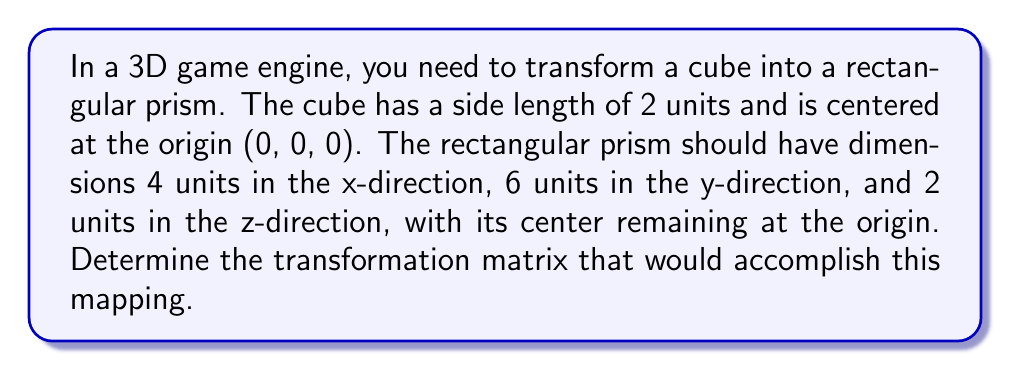Provide a solution to this math problem. To solve this problem, we need to follow these steps:

1) First, let's consider the transformation needed for each dimension:
   - x-axis: from 2 to 4 units (scale by 2)
   - y-axis: from 2 to 6 units (scale by 3)
   - z-axis: from 2 to 2 units (no change, scale by 1)

2) In 3D transformations, we use 4x4 matrices to represent scaling, rotation, and translation. The general form of a scaling matrix is:

   $$
   \begin{bmatrix}
   s_x & 0 & 0 & 0 \\
   0 & s_y & 0 & 0 \\
   0 & 0 & s_z & 0 \\
   0 & 0 & 0 & 1
   \end{bmatrix}
   $$

   where $s_x$, $s_y$, and $s_z$ are the scaling factors for x, y, and z axes respectively.

3) Substituting our scaling factors:

   $$
   \begin{bmatrix}
   2 & 0 & 0 & 0 \\
   0 & 3 & 0 & 0 \\
   0 & 0 & 1 & 0 \\
   0 & 0 & 0 & 1
   \end{bmatrix}
   $$

4) This matrix, when applied to any point $(x, y, z)$ of the cube, will transform it to the corresponding point on the rectangular prism:

   $$
   \begin{bmatrix}
   2 & 0 & 0 & 0 \\
   0 & 3 & 0 & 0 \\
   0 & 0 & 1 & 0 \\
   0 & 0 & 0 & 1
   \end{bmatrix}
   \begin{bmatrix}
   x \\
   y \\
   z \\
   1
   \end{bmatrix}
   =
   \begin{bmatrix}
   2x \\
   3y \\
   z \\
   1
   \end{bmatrix}
   $$

5) Note that we don't need any translation as both shapes are centered at the origin.
Answer: The transformation matrix to map the cube onto the rectangular prism is:

$$
\begin{bmatrix}
2 & 0 & 0 & 0 \\
0 & 3 & 0 & 0 \\
0 & 0 & 1 & 0 \\
0 & 0 & 0 & 1
\end{bmatrix}
$$ 